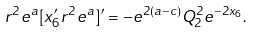Convert formula to latex. <formula><loc_0><loc_0><loc_500><loc_500>r ^ { 2 } e ^ { a } [ x _ { 6 } ^ { \prime } r ^ { 2 } e ^ { a } ] ^ { \prime } = - e ^ { 2 ( a - c ) } Q _ { 2 } ^ { 2 } e ^ { - 2 x _ { 6 } } .</formula> 